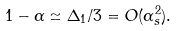Convert formula to latex. <formula><loc_0><loc_0><loc_500><loc_500>1 - \alpha \simeq \Delta _ { 1 } / 3 = O ( \alpha _ { s } ^ { 2 } ) .</formula> 